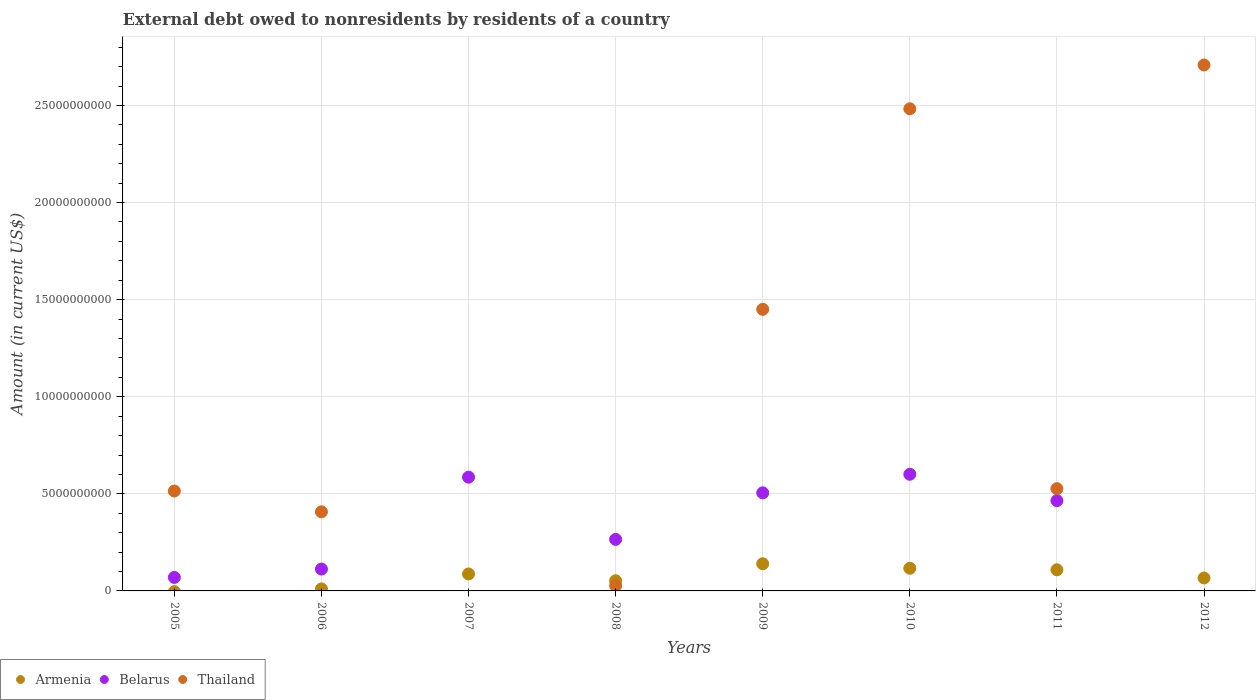What is the external debt owed by residents in Belarus in 2009?
Give a very brief answer. 5.05e+09. Across all years, what is the maximum external debt owed by residents in Belarus?
Offer a terse response. 6.01e+09. Across all years, what is the minimum external debt owed by residents in Thailand?
Your answer should be compact. 0. What is the total external debt owed by residents in Thailand in the graph?
Make the answer very short. 8.12e+1. What is the difference between the external debt owed by residents in Armenia in 2007 and that in 2011?
Provide a short and direct response. -2.15e+08. What is the difference between the external debt owed by residents in Thailand in 2007 and the external debt owed by residents in Belarus in 2009?
Your answer should be compact. -5.05e+09. What is the average external debt owed by residents in Belarus per year?
Your response must be concise. 3.26e+09. In the year 2010, what is the difference between the external debt owed by residents in Armenia and external debt owed by residents in Thailand?
Ensure brevity in your answer.  -2.37e+1. In how many years, is the external debt owed by residents in Armenia greater than 25000000000 US$?
Provide a succinct answer. 0. Is the external debt owed by residents in Thailand in 2008 less than that in 2009?
Provide a short and direct response. Yes. What is the difference between the highest and the second highest external debt owed by residents in Armenia?
Keep it short and to the point. 2.31e+08. What is the difference between the highest and the lowest external debt owed by residents in Belarus?
Offer a terse response. 6.01e+09. Is the external debt owed by residents in Armenia strictly less than the external debt owed by residents in Thailand over the years?
Provide a succinct answer. No. How many years are there in the graph?
Your answer should be compact. 8. What is the difference between two consecutive major ticks on the Y-axis?
Ensure brevity in your answer.  5.00e+09. Are the values on the major ticks of Y-axis written in scientific E-notation?
Provide a succinct answer. No. How many legend labels are there?
Give a very brief answer. 3. What is the title of the graph?
Keep it short and to the point. External debt owed to nonresidents by residents of a country. What is the Amount (in current US$) in Belarus in 2005?
Keep it short and to the point. 6.96e+08. What is the Amount (in current US$) of Thailand in 2005?
Provide a short and direct response. 5.14e+09. What is the Amount (in current US$) in Armenia in 2006?
Give a very brief answer. 1.04e+08. What is the Amount (in current US$) of Belarus in 2006?
Provide a succinct answer. 1.13e+09. What is the Amount (in current US$) in Thailand in 2006?
Make the answer very short. 4.07e+09. What is the Amount (in current US$) in Armenia in 2007?
Make the answer very short. 8.73e+08. What is the Amount (in current US$) of Belarus in 2007?
Ensure brevity in your answer.  5.86e+09. What is the Amount (in current US$) in Thailand in 2007?
Make the answer very short. 0. What is the Amount (in current US$) in Armenia in 2008?
Make the answer very short. 5.24e+08. What is the Amount (in current US$) of Belarus in 2008?
Make the answer very short. 2.65e+09. What is the Amount (in current US$) of Thailand in 2008?
Provide a succinct answer. 2.65e+08. What is the Amount (in current US$) in Armenia in 2009?
Give a very brief answer. 1.40e+09. What is the Amount (in current US$) in Belarus in 2009?
Give a very brief answer. 5.05e+09. What is the Amount (in current US$) of Thailand in 2009?
Make the answer very short. 1.45e+1. What is the Amount (in current US$) in Armenia in 2010?
Make the answer very short. 1.17e+09. What is the Amount (in current US$) of Belarus in 2010?
Provide a succinct answer. 6.01e+09. What is the Amount (in current US$) in Thailand in 2010?
Offer a very short reply. 2.48e+1. What is the Amount (in current US$) of Armenia in 2011?
Ensure brevity in your answer.  1.09e+09. What is the Amount (in current US$) of Belarus in 2011?
Keep it short and to the point. 4.65e+09. What is the Amount (in current US$) of Thailand in 2011?
Ensure brevity in your answer.  5.27e+09. What is the Amount (in current US$) in Armenia in 2012?
Provide a succinct answer. 6.65e+08. What is the Amount (in current US$) in Belarus in 2012?
Your response must be concise. 0. What is the Amount (in current US$) in Thailand in 2012?
Make the answer very short. 2.71e+1. Across all years, what is the maximum Amount (in current US$) of Armenia?
Your answer should be compact. 1.40e+09. Across all years, what is the maximum Amount (in current US$) of Belarus?
Give a very brief answer. 6.01e+09. Across all years, what is the maximum Amount (in current US$) of Thailand?
Keep it short and to the point. 2.71e+1. Across all years, what is the minimum Amount (in current US$) in Thailand?
Your answer should be compact. 0. What is the total Amount (in current US$) of Armenia in the graph?
Provide a succinct answer. 5.82e+09. What is the total Amount (in current US$) of Belarus in the graph?
Ensure brevity in your answer.  2.60e+1. What is the total Amount (in current US$) in Thailand in the graph?
Your response must be concise. 8.12e+1. What is the difference between the Amount (in current US$) of Belarus in 2005 and that in 2006?
Ensure brevity in your answer.  -4.31e+08. What is the difference between the Amount (in current US$) in Thailand in 2005 and that in 2006?
Provide a succinct answer. 1.07e+09. What is the difference between the Amount (in current US$) of Belarus in 2005 and that in 2007?
Ensure brevity in your answer.  -5.16e+09. What is the difference between the Amount (in current US$) in Belarus in 2005 and that in 2008?
Your answer should be compact. -1.96e+09. What is the difference between the Amount (in current US$) in Thailand in 2005 and that in 2008?
Provide a succinct answer. 4.88e+09. What is the difference between the Amount (in current US$) of Belarus in 2005 and that in 2009?
Offer a terse response. -4.36e+09. What is the difference between the Amount (in current US$) in Thailand in 2005 and that in 2009?
Keep it short and to the point. -9.36e+09. What is the difference between the Amount (in current US$) in Belarus in 2005 and that in 2010?
Your answer should be very brief. -5.31e+09. What is the difference between the Amount (in current US$) in Thailand in 2005 and that in 2010?
Give a very brief answer. -1.97e+1. What is the difference between the Amount (in current US$) in Belarus in 2005 and that in 2011?
Ensure brevity in your answer.  -3.95e+09. What is the difference between the Amount (in current US$) of Thailand in 2005 and that in 2011?
Your answer should be very brief. -1.21e+08. What is the difference between the Amount (in current US$) of Thailand in 2005 and that in 2012?
Make the answer very short. -2.19e+1. What is the difference between the Amount (in current US$) in Armenia in 2006 and that in 2007?
Provide a succinct answer. -7.69e+08. What is the difference between the Amount (in current US$) in Belarus in 2006 and that in 2007?
Offer a terse response. -4.73e+09. What is the difference between the Amount (in current US$) in Armenia in 2006 and that in 2008?
Your answer should be very brief. -4.20e+08. What is the difference between the Amount (in current US$) of Belarus in 2006 and that in 2008?
Provide a short and direct response. -1.53e+09. What is the difference between the Amount (in current US$) of Thailand in 2006 and that in 2008?
Offer a very short reply. 3.81e+09. What is the difference between the Amount (in current US$) of Armenia in 2006 and that in 2009?
Your response must be concise. -1.29e+09. What is the difference between the Amount (in current US$) in Belarus in 2006 and that in 2009?
Provide a succinct answer. -3.92e+09. What is the difference between the Amount (in current US$) in Thailand in 2006 and that in 2009?
Give a very brief answer. -1.04e+1. What is the difference between the Amount (in current US$) in Armenia in 2006 and that in 2010?
Provide a short and direct response. -1.06e+09. What is the difference between the Amount (in current US$) of Belarus in 2006 and that in 2010?
Your response must be concise. -4.88e+09. What is the difference between the Amount (in current US$) of Thailand in 2006 and that in 2010?
Your answer should be very brief. -2.08e+1. What is the difference between the Amount (in current US$) in Armenia in 2006 and that in 2011?
Keep it short and to the point. -9.83e+08. What is the difference between the Amount (in current US$) in Belarus in 2006 and that in 2011?
Your answer should be compact. -3.52e+09. What is the difference between the Amount (in current US$) of Thailand in 2006 and that in 2011?
Offer a terse response. -1.19e+09. What is the difference between the Amount (in current US$) of Armenia in 2006 and that in 2012?
Keep it short and to the point. -5.61e+08. What is the difference between the Amount (in current US$) in Thailand in 2006 and that in 2012?
Provide a short and direct response. -2.30e+1. What is the difference between the Amount (in current US$) of Armenia in 2007 and that in 2008?
Offer a very short reply. 3.49e+08. What is the difference between the Amount (in current US$) in Belarus in 2007 and that in 2008?
Your answer should be compact. 3.20e+09. What is the difference between the Amount (in current US$) of Armenia in 2007 and that in 2009?
Your response must be concise. -5.25e+08. What is the difference between the Amount (in current US$) of Belarus in 2007 and that in 2009?
Keep it short and to the point. 8.07e+08. What is the difference between the Amount (in current US$) of Armenia in 2007 and that in 2010?
Ensure brevity in your answer.  -2.94e+08. What is the difference between the Amount (in current US$) in Belarus in 2007 and that in 2010?
Offer a terse response. -1.50e+08. What is the difference between the Amount (in current US$) of Armenia in 2007 and that in 2011?
Offer a very short reply. -2.15e+08. What is the difference between the Amount (in current US$) of Belarus in 2007 and that in 2011?
Provide a succinct answer. 1.21e+09. What is the difference between the Amount (in current US$) of Armenia in 2007 and that in 2012?
Your response must be concise. 2.07e+08. What is the difference between the Amount (in current US$) in Armenia in 2008 and that in 2009?
Make the answer very short. -8.75e+08. What is the difference between the Amount (in current US$) of Belarus in 2008 and that in 2009?
Keep it short and to the point. -2.40e+09. What is the difference between the Amount (in current US$) of Thailand in 2008 and that in 2009?
Keep it short and to the point. -1.42e+1. What is the difference between the Amount (in current US$) in Armenia in 2008 and that in 2010?
Your answer should be compact. -6.43e+08. What is the difference between the Amount (in current US$) of Belarus in 2008 and that in 2010?
Offer a terse response. -3.35e+09. What is the difference between the Amount (in current US$) of Thailand in 2008 and that in 2010?
Offer a terse response. -2.46e+1. What is the difference between the Amount (in current US$) in Armenia in 2008 and that in 2011?
Keep it short and to the point. -5.64e+08. What is the difference between the Amount (in current US$) of Belarus in 2008 and that in 2011?
Make the answer very short. -1.99e+09. What is the difference between the Amount (in current US$) of Thailand in 2008 and that in 2011?
Your answer should be compact. -5.00e+09. What is the difference between the Amount (in current US$) of Armenia in 2008 and that in 2012?
Ensure brevity in your answer.  -1.42e+08. What is the difference between the Amount (in current US$) in Thailand in 2008 and that in 2012?
Offer a terse response. -2.68e+1. What is the difference between the Amount (in current US$) in Armenia in 2009 and that in 2010?
Provide a succinct answer. 2.31e+08. What is the difference between the Amount (in current US$) in Belarus in 2009 and that in 2010?
Your answer should be very brief. -9.57e+08. What is the difference between the Amount (in current US$) of Thailand in 2009 and that in 2010?
Your answer should be compact. -1.03e+1. What is the difference between the Amount (in current US$) of Armenia in 2009 and that in 2011?
Your answer should be very brief. 3.11e+08. What is the difference between the Amount (in current US$) in Belarus in 2009 and that in 2011?
Provide a short and direct response. 4.03e+08. What is the difference between the Amount (in current US$) of Thailand in 2009 and that in 2011?
Make the answer very short. 9.24e+09. What is the difference between the Amount (in current US$) of Armenia in 2009 and that in 2012?
Your response must be concise. 7.33e+08. What is the difference between the Amount (in current US$) in Thailand in 2009 and that in 2012?
Offer a very short reply. -1.26e+1. What is the difference between the Amount (in current US$) in Armenia in 2010 and that in 2011?
Your answer should be very brief. 7.94e+07. What is the difference between the Amount (in current US$) of Belarus in 2010 and that in 2011?
Keep it short and to the point. 1.36e+09. What is the difference between the Amount (in current US$) in Thailand in 2010 and that in 2011?
Provide a short and direct response. 1.96e+1. What is the difference between the Amount (in current US$) of Armenia in 2010 and that in 2012?
Provide a short and direct response. 5.01e+08. What is the difference between the Amount (in current US$) of Thailand in 2010 and that in 2012?
Offer a terse response. -2.26e+09. What is the difference between the Amount (in current US$) of Armenia in 2011 and that in 2012?
Keep it short and to the point. 4.22e+08. What is the difference between the Amount (in current US$) in Thailand in 2011 and that in 2012?
Offer a terse response. -2.18e+1. What is the difference between the Amount (in current US$) in Belarus in 2005 and the Amount (in current US$) in Thailand in 2006?
Give a very brief answer. -3.38e+09. What is the difference between the Amount (in current US$) in Belarus in 2005 and the Amount (in current US$) in Thailand in 2008?
Provide a succinct answer. 4.31e+08. What is the difference between the Amount (in current US$) of Belarus in 2005 and the Amount (in current US$) of Thailand in 2009?
Offer a terse response. -1.38e+1. What is the difference between the Amount (in current US$) in Belarus in 2005 and the Amount (in current US$) in Thailand in 2010?
Provide a short and direct response. -2.41e+1. What is the difference between the Amount (in current US$) in Belarus in 2005 and the Amount (in current US$) in Thailand in 2011?
Provide a succinct answer. -4.57e+09. What is the difference between the Amount (in current US$) of Belarus in 2005 and the Amount (in current US$) of Thailand in 2012?
Keep it short and to the point. -2.64e+1. What is the difference between the Amount (in current US$) in Armenia in 2006 and the Amount (in current US$) in Belarus in 2007?
Your answer should be very brief. -5.75e+09. What is the difference between the Amount (in current US$) of Armenia in 2006 and the Amount (in current US$) of Belarus in 2008?
Offer a very short reply. -2.55e+09. What is the difference between the Amount (in current US$) of Armenia in 2006 and the Amount (in current US$) of Thailand in 2008?
Your response must be concise. -1.61e+08. What is the difference between the Amount (in current US$) in Belarus in 2006 and the Amount (in current US$) in Thailand in 2008?
Offer a very short reply. 8.62e+08. What is the difference between the Amount (in current US$) in Armenia in 2006 and the Amount (in current US$) in Belarus in 2009?
Provide a short and direct response. -4.95e+09. What is the difference between the Amount (in current US$) in Armenia in 2006 and the Amount (in current US$) in Thailand in 2009?
Provide a succinct answer. -1.44e+1. What is the difference between the Amount (in current US$) in Belarus in 2006 and the Amount (in current US$) in Thailand in 2009?
Your answer should be compact. -1.34e+1. What is the difference between the Amount (in current US$) in Armenia in 2006 and the Amount (in current US$) in Belarus in 2010?
Keep it short and to the point. -5.90e+09. What is the difference between the Amount (in current US$) in Armenia in 2006 and the Amount (in current US$) in Thailand in 2010?
Your answer should be compact. -2.47e+1. What is the difference between the Amount (in current US$) of Belarus in 2006 and the Amount (in current US$) of Thailand in 2010?
Offer a terse response. -2.37e+1. What is the difference between the Amount (in current US$) of Armenia in 2006 and the Amount (in current US$) of Belarus in 2011?
Make the answer very short. -4.54e+09. What is the difference between the Amount (in current US$) of Armenia in 2006 and the Amount (in current US$) of Thailand in 2011?
Provide a short and direct response. -5.16e+09. What is the difference between the Amount (in current US$) of Belarus in 2006 and the Amount (in current US$) of Thailand in 2011?
Make the answer very short. -4.14e+09. What is the difference between the Amount (in current US$) in Armenia in 2006 and the Amount (in current US$) in Thailand in 2012?
Your response must be concise. -2.70e+1. What is the difference between the Amount (in current US$) in Belarus in 2006 and the Amount (in current US$) in Thailand in 2012?
Provide a short and direct response. -2.60e+1. What is the difference between the Amount (in current US$) in Armenia in 2007 and the Amount (in current US$) in Belarus in 2008?
Your response must be concise. -1.78e+09. What is the difference between the Amount (in current US$) of Armenia in 2007 and the Amount (in current US$) of Thailand in 2008?
Ensure brevity in your answer.  6.08e+08. What is the difference between the Amount (in current US$) of Belarus in 2007 and the Amount (in current US$) of Thailand in 2008?
Provide a short and direct response. 5.59e+09. What is the difference between the Amount (in current US$) of Armenia in 2007 and the Amount (in current US$) of Belarus in 2009?
Provide a succinct answer. -4.18e+09. What is the difference between the Amount (in current US$) in Armenia in 2007 and the Amount (in current US$) in Thailand in 2009?
Your answer should be very brief. -1.36e+1. What is the difference between the Amount (in current US$) of Belarus in 2007 and the Amount (in current US$) of Thailand in 2009?
Provide a succinct answer. -8.64e+09. What is the difference between the Amount (in current US$) of Armenia in 2007 and the Amount (in current US$) of Belarus in 2010?
Offer a very short reply. -5.14e+09. What is the difference between the Amount (in current US$) of Armenia in 2007 and the Amount (in current US$) of Thailand in 2010?
Your response must be concise. -2.40e+1. What is the difference between the Amount (in current US$) in Belarus in 2007 and the Amount (in current US$) in Thailand in 2010?
Keep it short and to the point. -1.90e+1. What is the difference between the Amount (in current US$) in Armenia in 2007 and the Amount (in current US$) in Belarus in 2011?
Your answer should be very brief. -3.78e+09. What is the difference between the Amount (in current US$) of Armenia in 2007 and the Amount (in current US$) of Thailand in 2011?
Your response must be concise. -4.39e+09. What is the difference between the Amount (in current US$) in Belarus in 2007 and the Amount (in current US$) in Thailand in 2011?
Your response must be concise. 5.92e+08. What is the difference between the Amount (in current US$) of Armenia in 2007 and the Amount (in current US$) of Thailand in 2012?
Your answer should be very brief. -2.62e+1. What is the difference between the Amount (in current US$) of Belarus in 2007 and the Amount (in current US$) of Thailand in 2012?
Provide a succinct answer. -2.12e+1. What is the difference between the Amount (in current US$) of Armenia in 2008 and the Amount (in current US$) of Belarus in 2009?
Offer a terse response. -4.53e+09. What is the difference between the Amount (in current US$) in Armenia in 2008 and the Amount (in current US$) in Thailand in 2009?
Provide a succinct answer. -1.40e+1. What is the difference between the Amount (in current US$) of Belarus in 2008 and the Amount (in current US$) of Thailand in 2009?
Offer a terse response. -1.18e+1. What is the difference between the Amount (in current US$) of Armenia in 2008 and the Amount (in current US$) of Belarus in 2010?
Provide a short and direct response. -5.48e+09. What is the difference between the Amount (in current US$) of Armenia in 2008 and the Amount (in current US$) of Thailand in 2010?
Provide a succinct answer. -2.43e+1. What is the difference between the Amount (in current US$) in Belarus in 2008 and the Amount (in current US$) in Thailand in 2010?
Offer a very short reply. -2.22e+1. What is the difference between the Amount (in current US$) of Armenia in 2008 and the Amount (in current US$) of Belarus in 2011?
Your answer should be very brief. -4.12e+09. What is the difference between the Amount (in current US$) in Armenia in 2008 and the Amount (in current US$) in Thailand in 2011?
Provide a short and direct response. -4.74e+09. What is the difference between the Amount (in current US$) of Belarus in 2008 and the Amount (in current US$) of Thailand in 2011?
Your answer should be very brief. -2.61e+09. What is the difference between the Amount (in current US$) of Armenia in 2008 and the Amount (in current US$) of Thailand in 2012?
Your response must be concise. -2.66e+1. What is the difference between the Amount (in current US$) in Belarus in 2008 and the Amount (in current US$) in Thailand in 2012?
Provide a short and direct response. -2.44e+1. What is the difference between the Amount (in current US$) in Armenia in 2009 and the Amount (in current US$) in Belarus in 2010?
Provide a short and direct response. -4.61e+09. What is the difference between the Amount (in current US$) of Armenia in 2009 and the Amount (in current US$) of Thailand in 2010?
Provide a succinct answer. -2.34e+1. What is the difference between the Amount (in current US$) of Belarus in 2009 and the Amount (in current US$) of Thailand in 2010?
Provide a short and direct response. -1.98e+1. What is the difference between the Amount (in current US$) in Armenia in 2009 and the Amount (in current US$) in Belarus in 2011?
Keep it short and to the point. -3.25e+09. What is the difference between the Amount (in current US$) of Armenia in 2009 and the Amount (in current US$) of Thailand in 2011?
Your answer should be very brief. -3.87e+09. What is the difference between the Amount (in current US$) in Belarus in 2009 and the Amount (in current US$) in Thailand in 2011?
Your answer should be very brief. -2.15e+08. What is the difference between the Amount (in current US$) of Armenia in 2009 and the Amount (in current US$) of Thailand in 2012?
Your answer should be compact. -2.57e+1. What is the difference between the Amount (in current US$) in Belarus in 2009 and the Amount (in current US$) in Thailand in 2012?
Make the answer very short. -2.20e+1. What is the difference between the Amount (in current US$) in Armenia in 2010 and the Amount (in current US$) in Belarus in 2011?
Make the answer very short. -3.48e+09. What is the difference between the Amount (in current US$) of Armenia in 2010 and the Amount (in current US$) of Thailand in 2011?
Offer a terse response. -4.10e+09. What is the difference between the Amount (in current US$) in Belarus in 2010 and the Amount (in current US$) in Thailand in 2011?
Offer a terse response. 7.42e+08. What is the difference between the Amount (in current US$) of Armenia in 2010 and the Amount (in current US$) of Thailand in 2012?
Your answer should be compact. -2.59e+1. What is the difference between the Amount (in current US$) of Belarus in 2010 and the Amount (in current US$) of Thailand in 2012?
Offer a very short reply. -2.11e+1. What is the difference between the Amount (in current US$) in Armenia in 2011 and the Amount (in current US$) in Thailand in 2012?
Your answer should be very brief. -2.60e+1. What is the difference between the Amount (in current US$) in Belarus in 2011 and the Amount (in current US$) in Thailand in 2012?
Give a very brief answer. -2.24e+1. What is the average Amount (in current US$) in Armenia per year?
Offer a very short reply. 7.27e+08. What is the average Amount (in current US$) of Belarus per year?
Make the answer very short. 3.26e+09. What is the average Amount (in current US$) in Thailand per year?
Offer a very short reply. 1.01e+1. In the year 2005, what is the difference between the Amount (in current US$) in Belarus and Amount (in current US$) in Thailand?
Give a very brief answer. -4.45e+09. In the year 2006, what is the difference between the Amount (in current US$) in Armenia and Amount (in current US$) in Belarus?
Offer a very short reply. -1.02e+09. In the year 2006, what is the difference between the Amount (in current US$) of Armenia and Amount (in current US$) of Thailand?
Offer a very short reply. -3.97e+09. In the year 2006, what is the difference between the Amount (in current US$) of Belarus and Amount (in current US$) of Thailand?
Your response must be concise. -2.95e+09. In the year 2007, what is the difference between the Amount (in current US$) of Armenia and Amount (in current US$) of Belarus?
Give a very brief answer. -4.99e+09. In the year 2008, what is the difference between the Amount (in current US$) of Armenia and Amount (in current US$) of Belarus?
Offer a terse response. -2.13e+09. In the year 2008, what is the difference between the Amount (in current US$) of Armenia and Amount (in current US$) of Thailand?
Keep it short and to the point. 2.59e+08. In the year 2008, what is the difference between the Amount (in current US$) of Belarus and Amount (in current US$) of Thailand?
Provide a short and direct response. 2.39e+09. In the year 2009, what is the difference between the Amount (in current US$) of Armenia and Amount (in current US$) of Belarus?
Give a very brief answer. -3.65e+09. In the year 2009, what is the difference between the Amount (in current US$) of Armenia and Amount (in current US$) of Thailand?
Your response must be concise. -1.31e+1. In the year 2009, what is the difference between the Amount (in current US$) of Belarus and Amount (in current US$) of Thailand?
Give a very brief answer. -9.45e+09. In the year 2010, what is the difference between the Amount (in current US$) of Armenia and Amount (in current US$) of Belarus?
Ensure brevity in your answer.  -4.84e+09. In the year 2010, what is the difference between the Amount (in current US$) of Armenia and Amount (in current US$) of Thailand?
Offer a very short reply. -2.37e+1. In the year 2010, what is the difference between the Amount (in current US$) of Belarus and Amount (in current US$) of Thailand?
Your answer should be very brief. -1.88e+1. In the year 2011, what is the difference between the Amount (in current US$) of Armenia and Amount (in current US$) of Belarus?
Keep it short and to the point. -3.56e+09. In the year 2011, what is the difference between the Amount (in current US$) of Armenia and Amount (in current US$) of Thailand?
Your answer should be very brief. -4.18e+09. In the year 2011, what is the difference between the Amount (in current US$) in Belarus and Amount (in current US$) in Thailand?
Provide a succinct answer. -6.18e+08. In the year 2012, what is the difference between the Amount (in current US$) of Armenia and Amount (in current US$) of Thailand?
Provide a succinct answer. -2.64e+1. What is the ratio of the Amount (in current US$) of Belarus in 2005 to that in 2006?
Your response must be concise. 0.62. What is the ratio of the Amount (in current US$) of Thailand in 2005 to that in 2006?
Give a very brief answer. 1.26. What is the ratio of the Amount (in current US$) in Belarus in 2005 to that in 2007?
Your answer should be compact. 0.12. What is the ratio of the Amount (in current US$) of Belarus in 2005 to that in 2008?
Give a very brief answer. 0.26. What is the ratio of the Amount (in current US$) in Thailand in 2005 to that in 2008?
Make the answer very short. 19.42. What is the ratio of the Amount (in current US$) in Belarus in 2005 to that in 2009?
Ensure brevity in your answer.  0.14. What is the ratio of the Amount (in current US$) of Thailand in 2005 to that in 2009?
Keep it short and to the point. 0.35. What is the ratio of the Amount (in current US$) of Belarus in 2005 to that in 2010?
Give a very brief answer. 0.12. What is the ratio of the Amount (in current US$) of Thailand in 2005 to that in 2010?
Your answer should be compact. 0.21. What is the ratio of the Amount (in current US$) in Belarus in 2005 to that in 2011?
Your response must be concise. 0.15. What is the ratio of the Amount (in current US$) of Thailand in 2005 to that in 2011?
Make the answer very short. 0.98. What is the ratio of the Amount (in current US$) in Thailand in 2005 to that in 2012?
Provide a short and direct response. 0.19. What is the ratio of the Amount (in current US$) of Armenia in 2006 to that in 2007?
Ensure brevity in your answer.  0.12. What is the ratio of the Amount (in current US$) of Belarus in 2006 to that in 2007?
Your answer should be compact. 0.19. What is the ratio of the Amount (in current US$) of Armenia in 2006 to that in 2008?
Keep it short and to the point. 0.2. What is the ratio of the Amount (in current US$) in Belarus in 2006 to that in 2008?
Offer a very short reply. 0.42. What is the ratio of the Amount (in current US$) in Thailand in 2006 to that in 2008?
Keep it short and to the point. 15.37. What is the ratio of the Amount (in current US$) of Armenia in 2006 to that in 2009?
Offer a very short reply. 0.07. What is the ratio of the Amount (in current US$) of Belarus in 2006 to that in 2009?
Your answer should be compact. 0.22. What is the ratio of the Amount (in current US$) of Thailand in 2006 to that in 2009?
Your answer should be very brief. 0.28. What is the ratio of the Amount (in current US$) in Armenia in 2006 to that in 2010?
Your response must be concise. 0.09. What is the ratio of the Amount (in current US$) in Belarus in 2006 to that in 2010?
Provide a succinct answer. 0.19. What is the ratio of the Amount (in current US$) of Thailand in 2006 to that in 2010?
Ensure brevity in your answer.  0.16. What is the ratio of the Amount (in current US$) in Armenia in 2006 to that in 2011?
Make the answer very short. 0.1. What is the ratio of the Amount (in current US$) of Belarus in 2006 to that in 2011?
Your response must be concise. 0.24. What is the ratio of the Amount (in current US$) of Thailand in 2006 to that in 2011?
Give a very brief answer. 0.77. What is the ratio of the Amount (in current US$) of Armenia in 2006 to that in 2012?
Make the answer very short. 0.16. What is the ratio of the Amount (in current US$) in Thailand in 2006 to that in 2012?
Offer a very short reply. 0.15. What is the ratio of the Amount (in current US$) in Armenia in 2007 to that in 2008?
Give a very brief answer. 1.67. What is the ratio of the Amount (in current US$) in Belarus in 2007 to that in 2008?
Your answer should be very brief. 2.21. What is the ratio of the Amount (in current US$) of Armenia in 2007 to that in 2009?
Your answer should be compact. 0.62. What is the ratio of the Amount (in current US$) in Belarus in 2007 to that in 2009?
Your answer should be compact. 1.16. What is the ratio of the Amount (in current US$) in Armenia in 2007 to that in 2010?
Provide a short and direct response. 0.75. What is the ratio of the Amount (in current US$) in Armenia in 2007 to that in 2011?
Your answer should be very brief. 0.8. What is the ratio of the Amount (in current US$) of Belarus in 2007 to that in 2011?
Keep it short and to the point. 1.26. What is the ratio of the Amount (in current US$) of Armenia in 2007 to that in 2012?
Ensure brevity in your answer.  1.31. What is the ratio of the Amount (in current US$) of Armenia in 2008 to that in 2009?
Your answer should be compact. 0.37. What is the ratio of the Amount (in current US$) of Belarus in 2008 to that in 2009?
Offer a very short reply. 0.53. What is the ratio of the Amount (in current US$) in Thailand in 2008 to that in 2009?
Keep it short and to the point. 0.02. What is the ratio of the Amount (in current US$) of Armenia in 2008 to that in 2010?
Keep it short and to the point. 0.45. What is the ratio of the Amount (in current US$) of Belarus in 2008 to that in 2010?
Ensure brevity in your answer.  0.44. What is the ratio of the Amount (in current US$) of Thailand in 2008 to that in 2010?
Ensure brevity in your answer.  0.01. What is the ratio of the Amount (in current US$) of Armenia in 2008 to that in 2011?
Your answer should be very brief. 0.48. What is the ratio of the Amount (in current US$) of Belarus in 2008 to that in 2011?
Give a very brief answer. 0.57. What is the ratio of the Amount (in current US$) in Thailand in 2008 to that in 2011?
Provide a short and direct response. 0.05. What is the ratio of the Amount (in current US$) in Armenia in 2008 to that in 2012?
Your response must be concise. 0.79. What is the ratio of the Amount (in current US$) of Thailand in 2008 to that in 2012?
Keep it short and to the point. 0.01. What is the ratio of the Amount (in current US$) of Armenia in 2009 to that in 2010?
Your answer should be compact. 1.2. What is the ratio of the Amount (in current US$) of Belarus in 2009 to that in 2010?
Give a very brief answer. 0.84. What is the ratio of the Amount (in current US$) of Thailand in 2009 to that in 2010?
Offer a very short reply. 0.58. What is the ratio of the Amount (in current US$) of Armenia in 2009 to that in 2011?
Your response must be concise. 1.29. What is the ratio of the Amount (in current US$) of Belarus in 2009 to that in 2011?
Provide a succinct answer. 1.09. What is the ratio of the Amount (in current US$) in Thailand in 2009 to that in 2011?
Provide a short and direct response. 2.75. What is the ratio of the Amount (in current US$) of Armenia in 2009 to that in 2012?
Your response must be concise. 2.1. What is the ratio of the Amount (in current US$) in Thailand in 2009 to that in 2012?
Your answer should be very brief. 0.54. What is the ratio of the Amount (in current US$) in Armenia in 2010 to that in 2011?
Provide a short and direct response. 1.07. What is the ratio of the Amount (in current US$) of Belarus in 2010 to that in 2011?
Offer a terse response. 1.29. What is the ratio of the Amount (in current US$) of Thailand in 2010 to that in 2011?
Offer a very short reply. 4.72. What is the ratio of the Amount (in current US$) in Armenia in 2010 to that in 2012?
Your answer should be compact. 1.75. What is the ratio of the Amount (in current US$) in Armenia in 2011 to that in 2012?
Keep it short and to the point. 1.63. What is the ratio of the Amount (in current US$) in Thailand in 2011 to that in 2012?
Keep it short and to the point. 0.19. What is the difference between the highest and the second highest Amount (in current US$) of Armenia?
Ensure brevity in your answer.  2.31e+08. What is the difference between the highest and the second highest Amount (in current US$) in Belarus?
Make the answer very short. 1.50e+08. What is the difference between the highest and the second highest Amount (in current US$) of Thailand?
Provide a succinct answer. 2.26e+09. What is the difference between the highest and the lowest Amount (in current US$) in Armenia?
Give a very brief answer. 1.40e+09. What is the difference between the highest and the lowest Amount (in current US$) in Belarus?
Your response must be concise. 6.01e+09. What is the difference between the highest and the lowest Amount (in current US$) of Thailand?
Offer a terse response. 2.71e+1. 